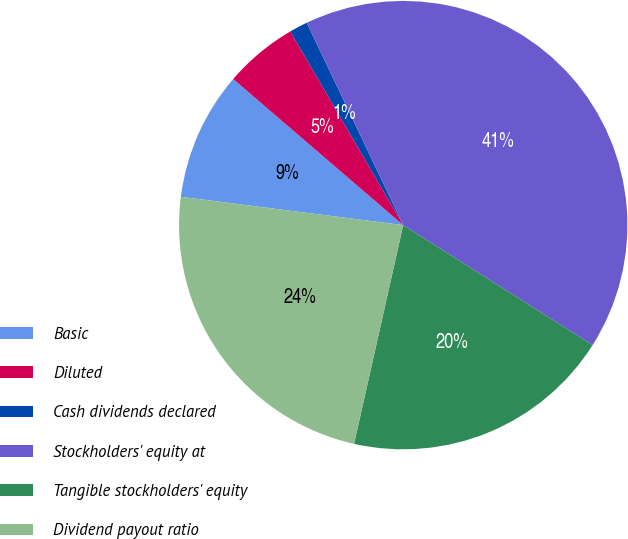<chart> <loc_0><loc_0><loc_500><loc_500><pie_chart><fcel>Basic<fcel>Diluted<fcel>Cash dividends declared<fcel>Stockholders' equity at<fcel>Tangible stockholders' equity<fcel>Dividend payout ratio<nl><fcel>9.28%<fcel>5.3%<fcel>1.32%<fcel>41.07%<fcel>19.53%<fcel>23.5%<nl></chart> 